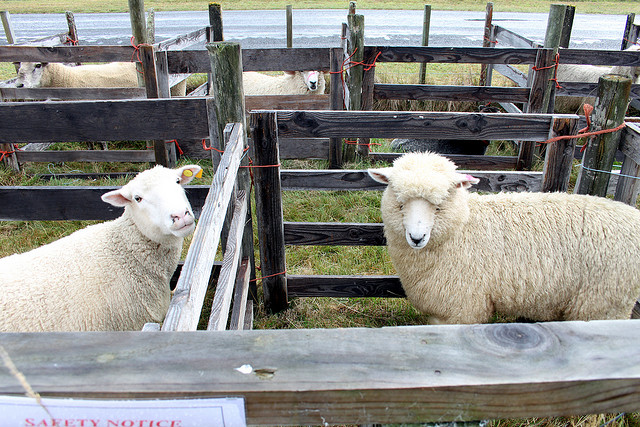Please extract the text content from this image. SAFETY NOTICE 